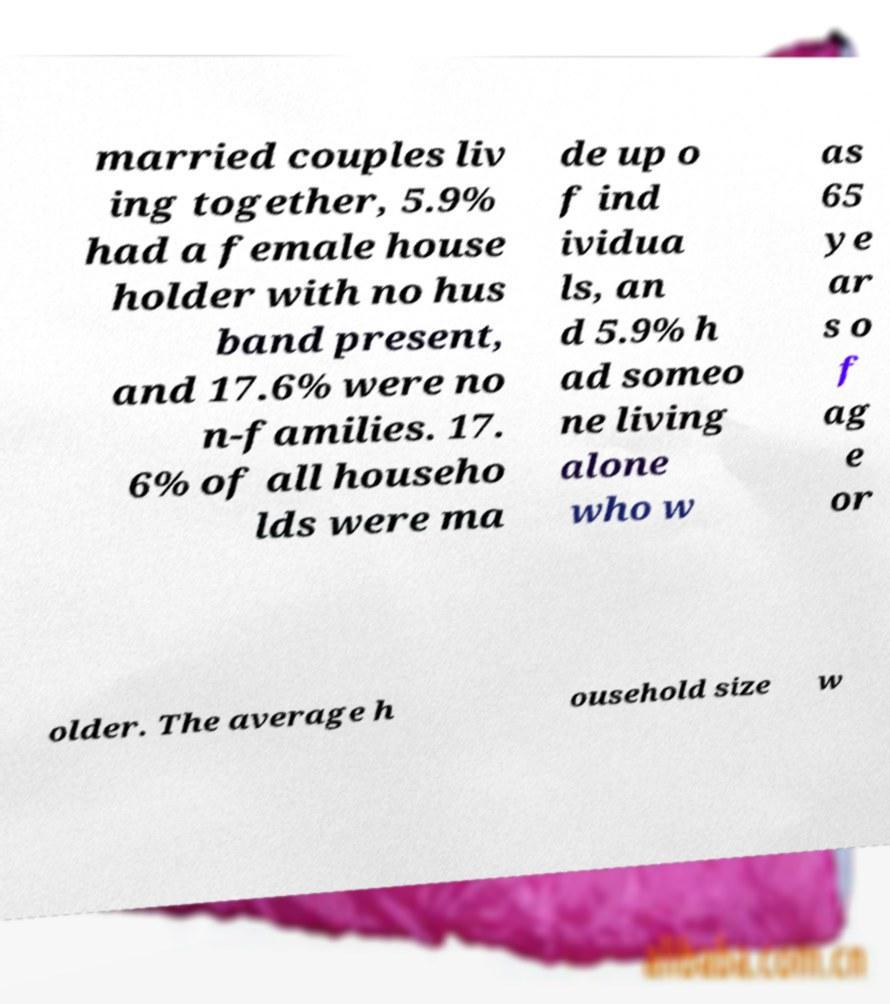I need the written content from this picture converted into text. Can you do that? married couples liv ing together, 5.9% had a female house holder with no hus band present, and 17.6% were no n-families. 17. 6% of all househo lds were ma de up o f ind ividua ls, an d 5.9% h ad someo ne living alone who w as 65 ye ar s o f ag e or older. The average h ousehold size w 